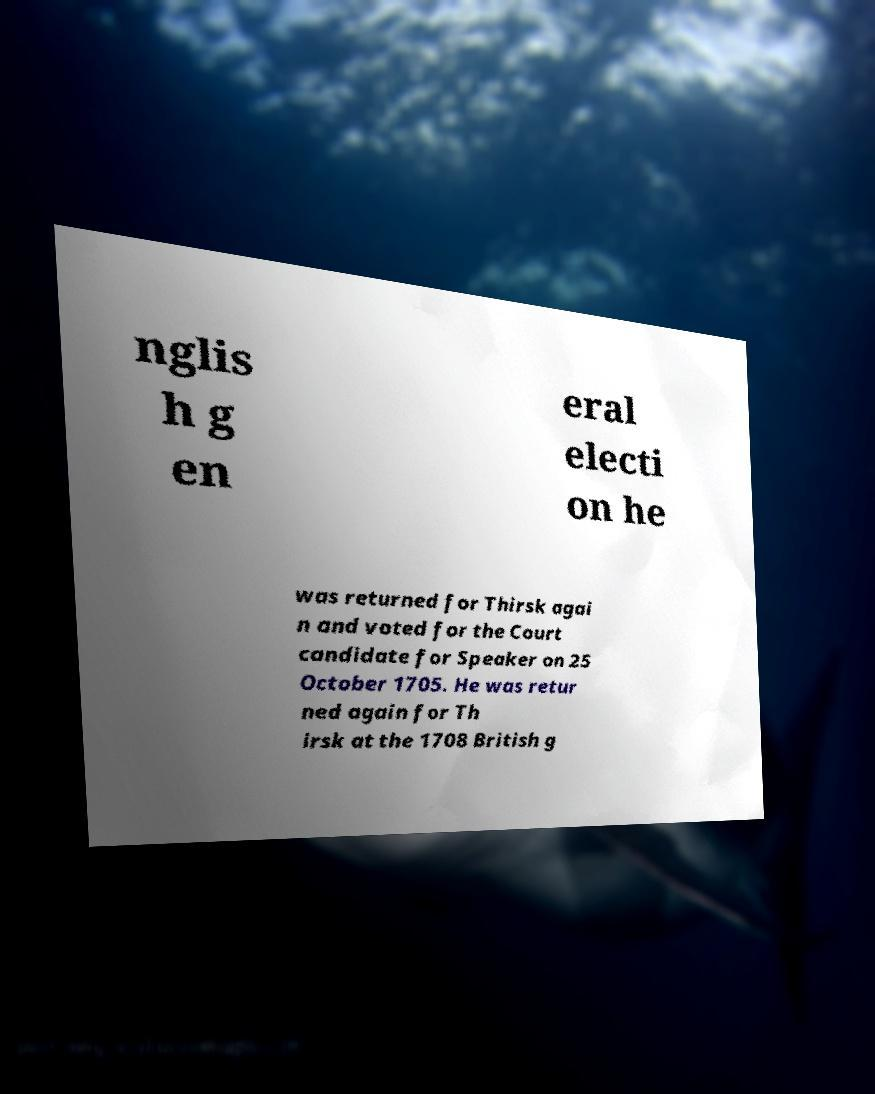Could you extract and type out the text from this image? nglis h g en eral electi on he was returned for Thirsk agai n and voted for the Court candidate for Speaker on 25 October 1705. He was retur ned again for Th irsk at the 1708 British g 